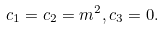Convert formula to latex. <formula><loc_0><loc_0><loc_500><loc_500>c _ { 1 } = c _ { 2 } = m ^ { 2 } , c _ { 3 } = 0 .</formula> 